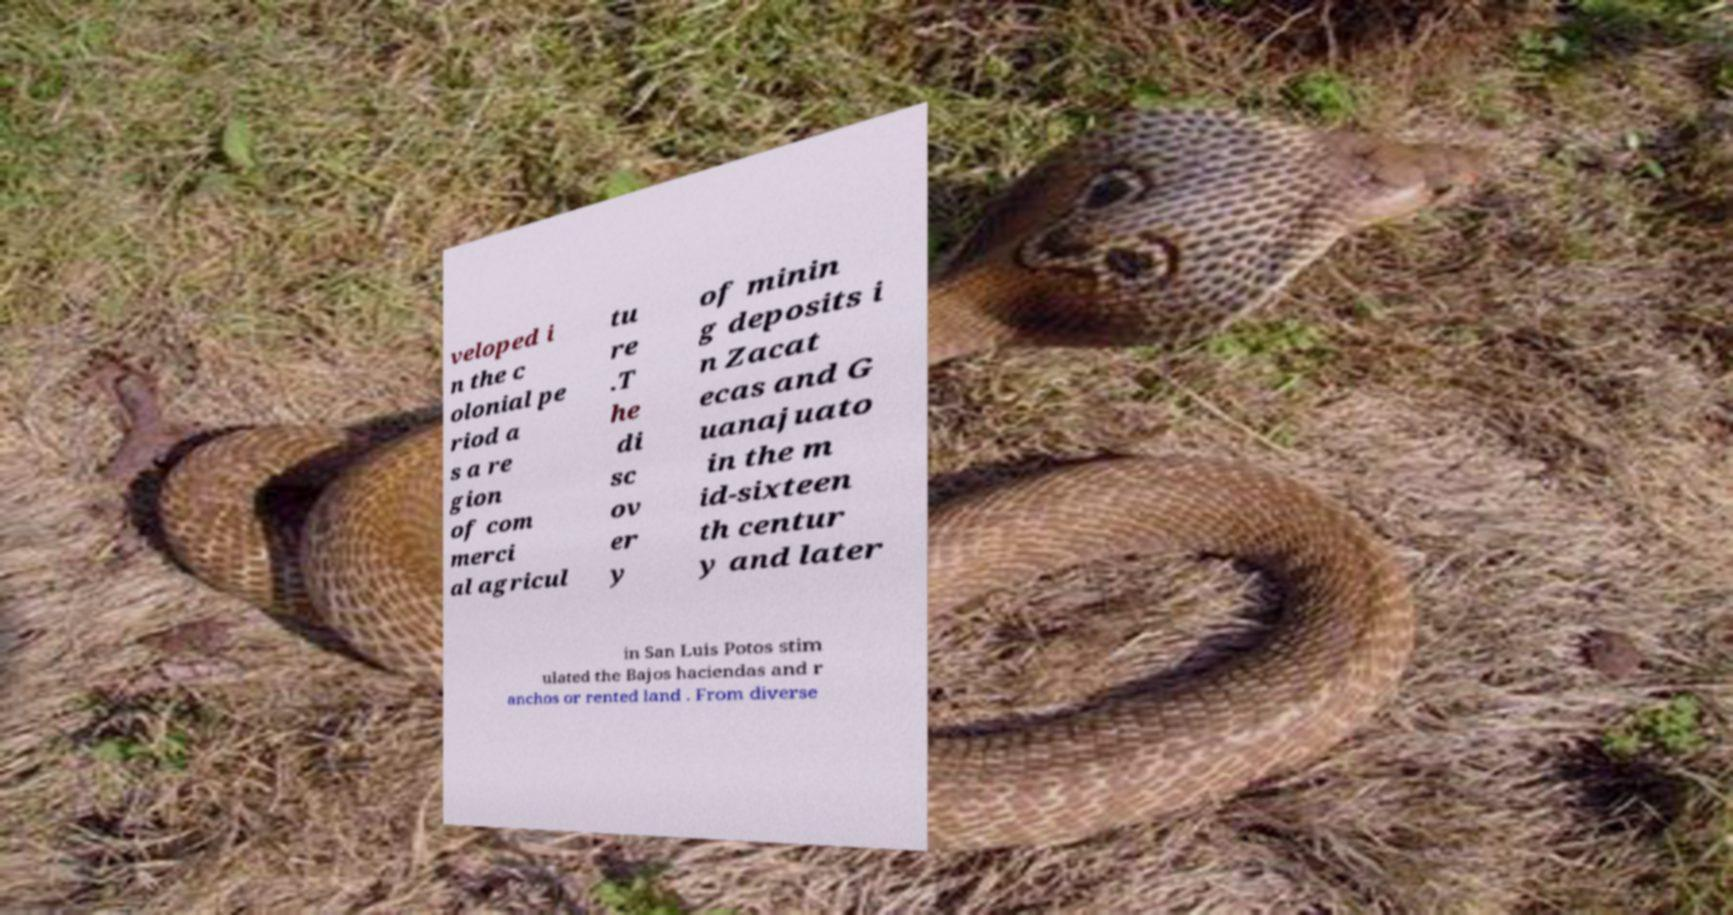Can you read and provide the text displayed in the image?This photo seems to have some interesting text. Can you extract and type it out for me? veloped i n the c olonial pe riod a s a re gion of com merci al agricul tu re .T he di sc ov er y of minin g deposits i n Zacat ecas and G uanajuato in the m id-sixteen th centur y and later in San Luis Potos stim ulated the Bajos haciendas and r anchos or rented land . From diverse 